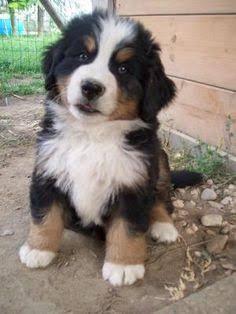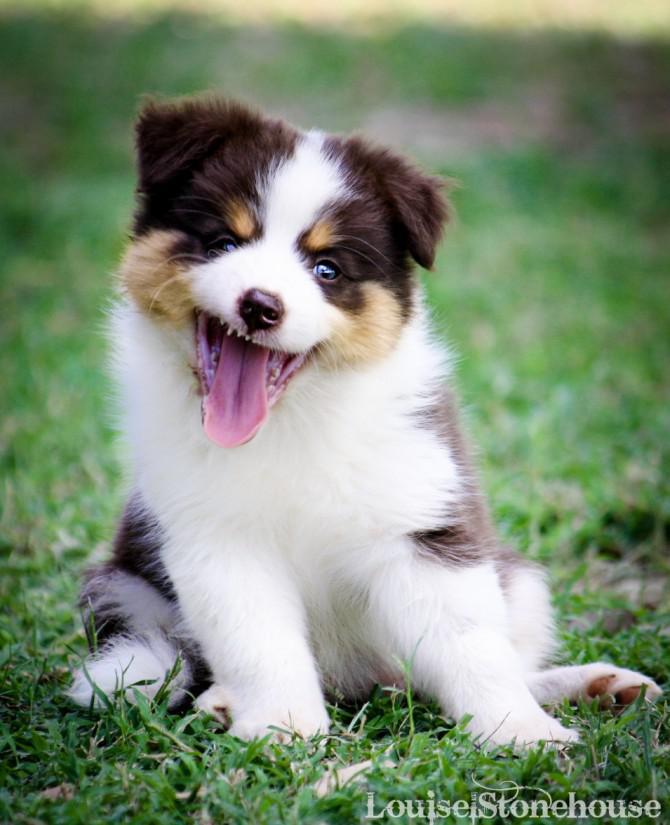The first image is the image on the left, the second image is the image on the right. Evaluate the accuracy of this statement regarding the images: "Each image features exactly two animals posed close together, and one image shows two dogs in a reclining position with front paws extended.". Is it true? Answer yes or no. No. The first image is the image on the left, the second image is the image on the right. For the images displayed, is the sentence "The right image contains exactly two dogs." factually correct? Answer yes or no. No. 